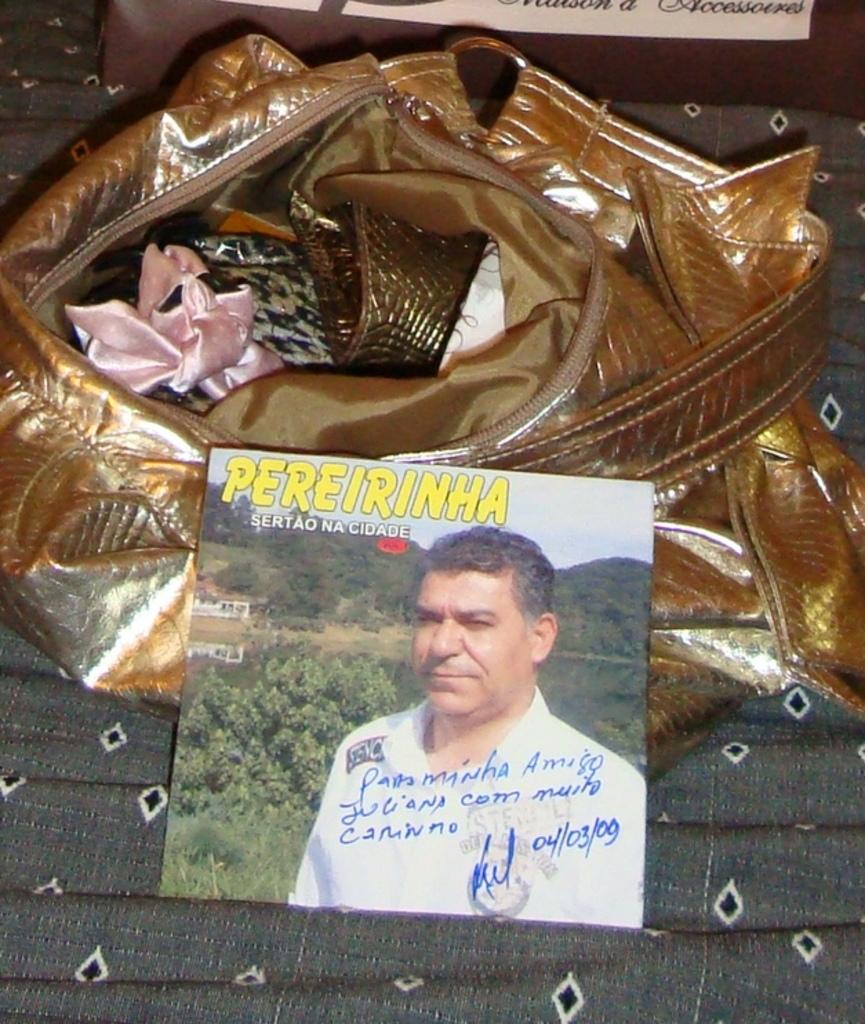What color is the purse in the image? The purse in the image is in golden brown color. What else can be seen in the image besides the purse? There is a photo of a person in the image. What is the person in the photo wearing? The person in the photo is wearing a white shirt. What can be seen in the background of the photo? The photo has a background of trees and a house. Is there a cellar visible in the image? No, there is no cellar present in the image. What type of cream is being used by the person in the photo? There is no cream visible in the image, and the person in the photo is not shown using any cream. 